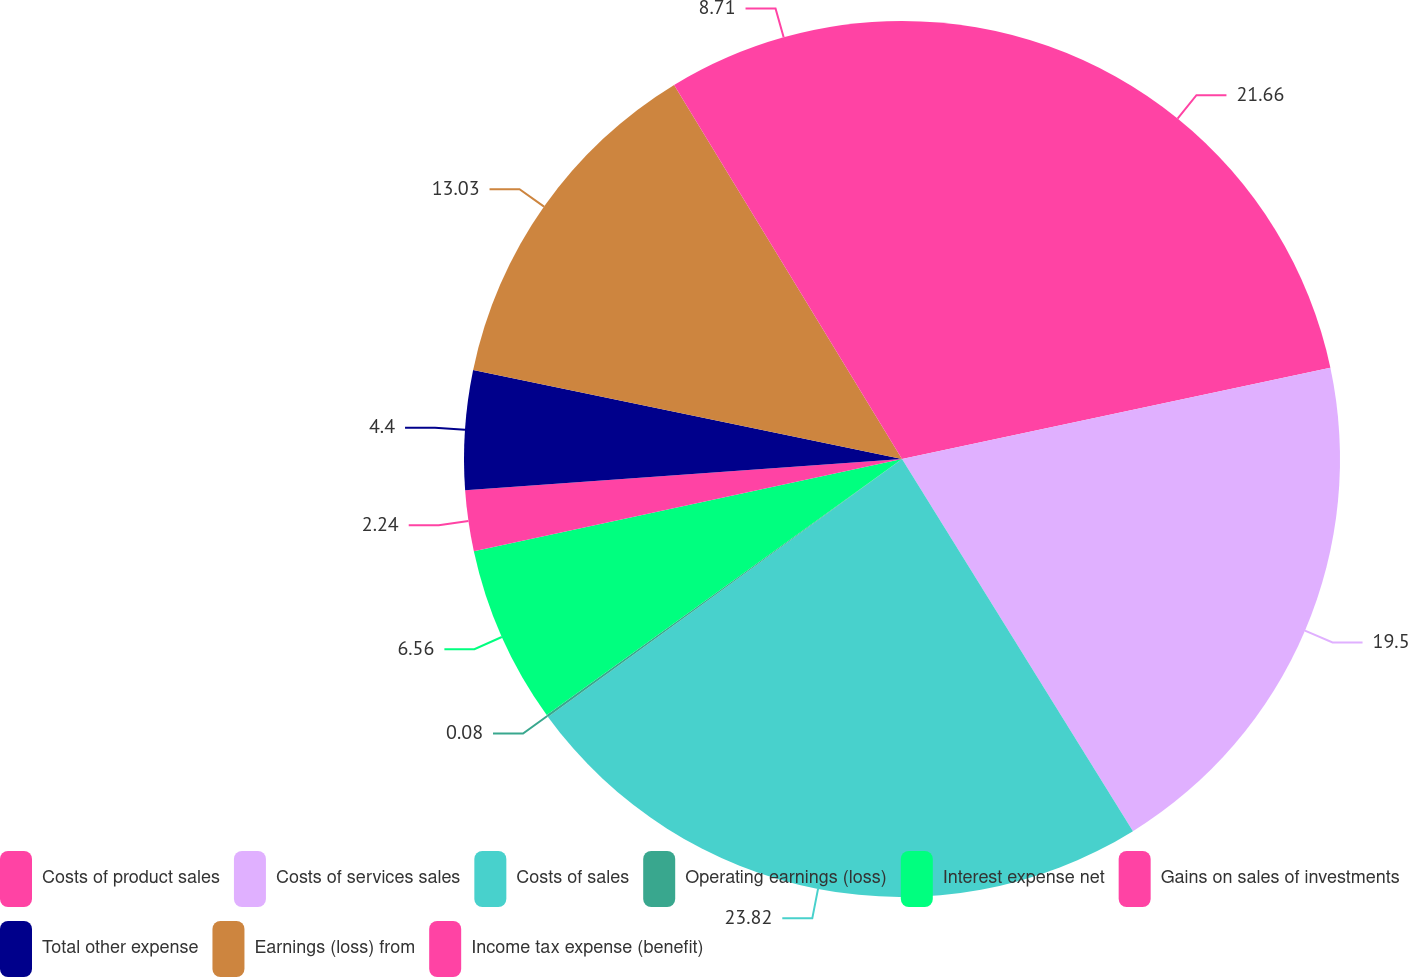Convert chart to OTSL. <chart><loc_0><loc_0><loc_500><loc_500><pie_chart><fcel>Costs of product sales<fcel>Costs of services sales<fcel>Costs of sales<fcel>Operating earnings (loss)<fcel>Interest expense net<fcel>Gains on sales of investments<fcel>Total other expense<fcel>Earnings (loss) from<fcel>Income tax expense (benefit)<nl><fcel>21.66%<fcel>19.5%<fcel>23.82%<fcel>0.08%<fcel>6.56%<fcel>2.24%<fcel>4.4%<fcel>13.03%<fcel>8.71%<nl></chart> 